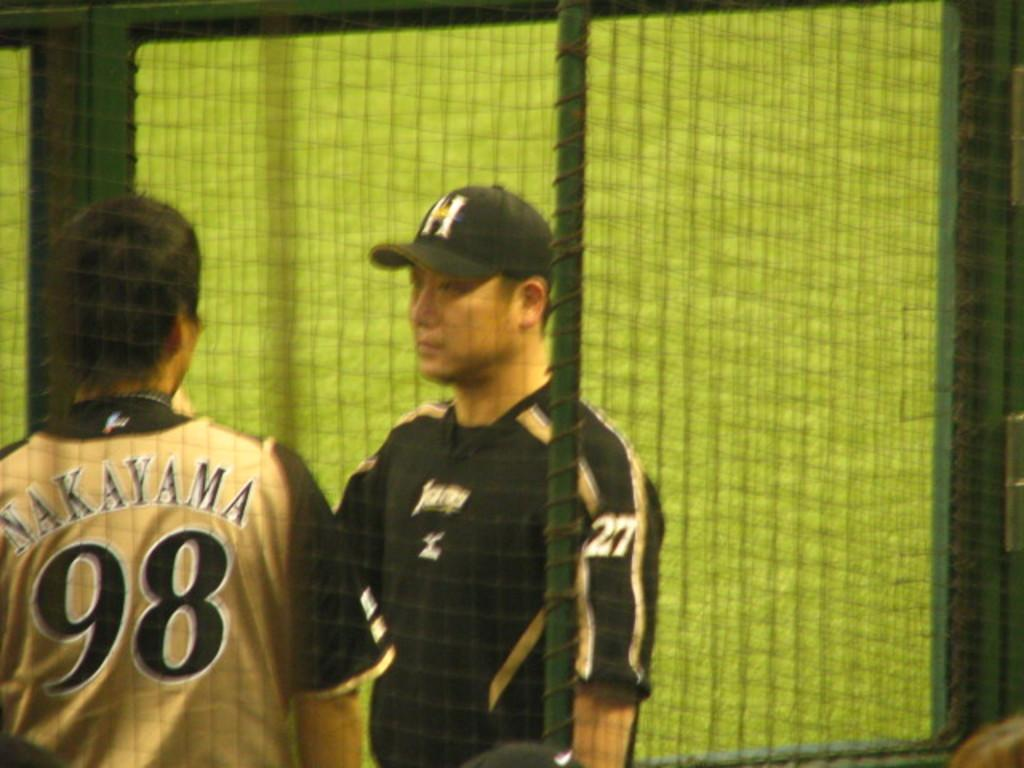<image>
Summarize the visual content of the image. A man with Nakayama and the number 98 on his shirt talks to another man 